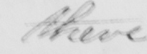What does this handwritten line say? there 